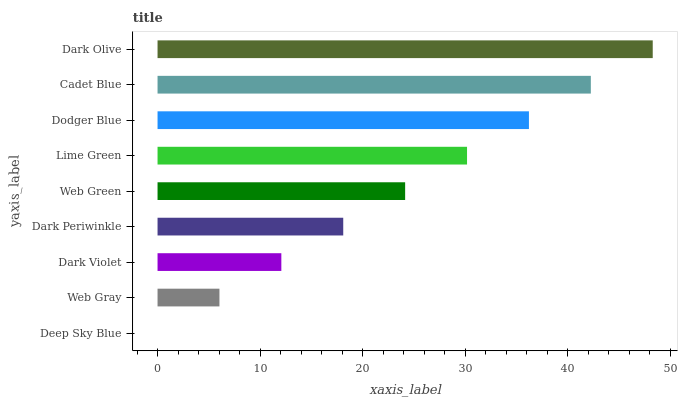Is Deep Sky Blue the minimum?
Answer yes or no. Yes. Is Dark Olive the maximum?
Answer yes or no. Yes. Is Web Gray the minimum?
Answer yes or no. No. Is Web Gray the maximum?
Answer yes or no. No. Is Web Gray greater than Deep Sky Blue?
Answer yes or no. Yes. Is Deep Sky Blue less than Web Gray?
Answer yes or no. Yes. Is Deep Sky Blue greater than Web Gray?
Answer yes or no. No. Is Web Gray less than Deep Sky Blue?
Answer yes or no. No. Is Web Green the high median?
Answer yes or no. Yes. Is Web Green the low median?
Answer yes or no. Yes. Is Lime Green the high median?
Answer yes or no. No. Is Web Gray the low median?
Answer yes or no. No. 